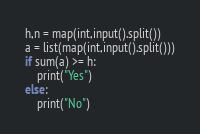Convert code to text. <code><loc_0><loc_0><loc_500><loc_500><_Python_>h,n = map(int,input().split())
a = list(map(int,input().split()))
if sum(a) >= h:
    print("Yes")
else:
    print("No")</code> 